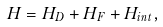<formula> <loc_0><loc_0><loc_500><loc_500>H = H _ { D } + H _ { F } + H _ { i n t } ,</formula> 